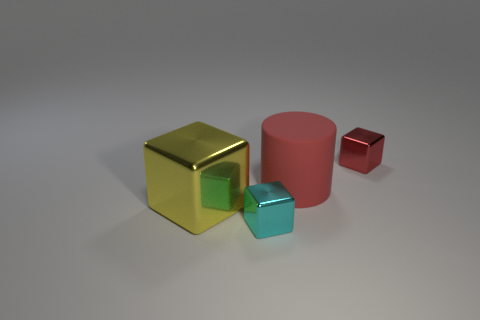Add 3 big red matte cylinders. How many objects exist? 7 Subtract all cylinders. How many objects are left? 3 Subtract all red metal things. Subtract all yellow metallic cubes. How many objects are left? 2 Add 1 large red rubber things. How many large red rubber things are left? 2 Add 1 big green spheres. How many big green spheres exist? 1 Subtract 0 yellow balls. How many objects are left? 4 